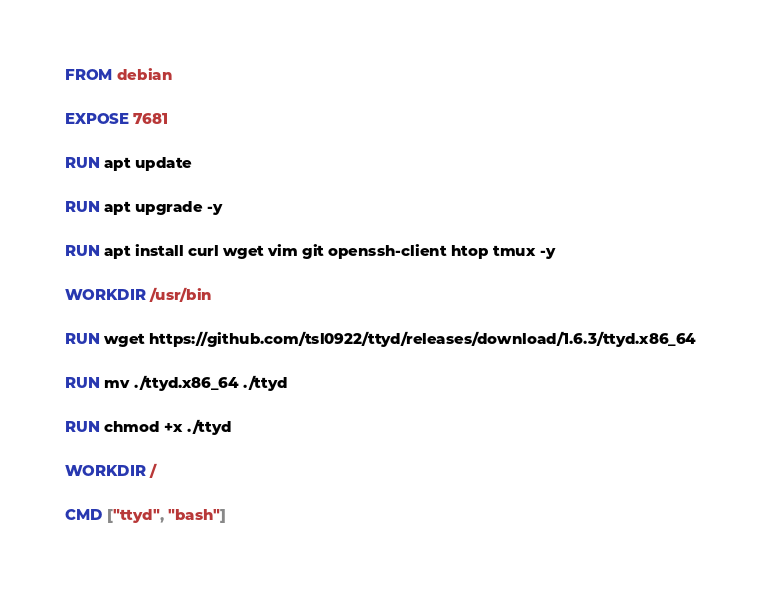Convert code to text. <code><loc_0><loc_0><loc_500><loc_500><_Dockerfile_>FROM debian

EXPOSE 7681

RUN apt update

RUN apt upgrade -y

RUN apt install curl wget vim git openssh-client htop tmux -y

WORKDIR /usr/bin

RUN wget https://github.com/tsl0922/ttyd/releases/download/1.6.3/ttyd.x86_64

RUN mv ./ttyd.x86_64 ./ttyd

RUN chmod +x ./ttyd

WORKDIR /

CMD ["ttyd", "bash"]</code> 